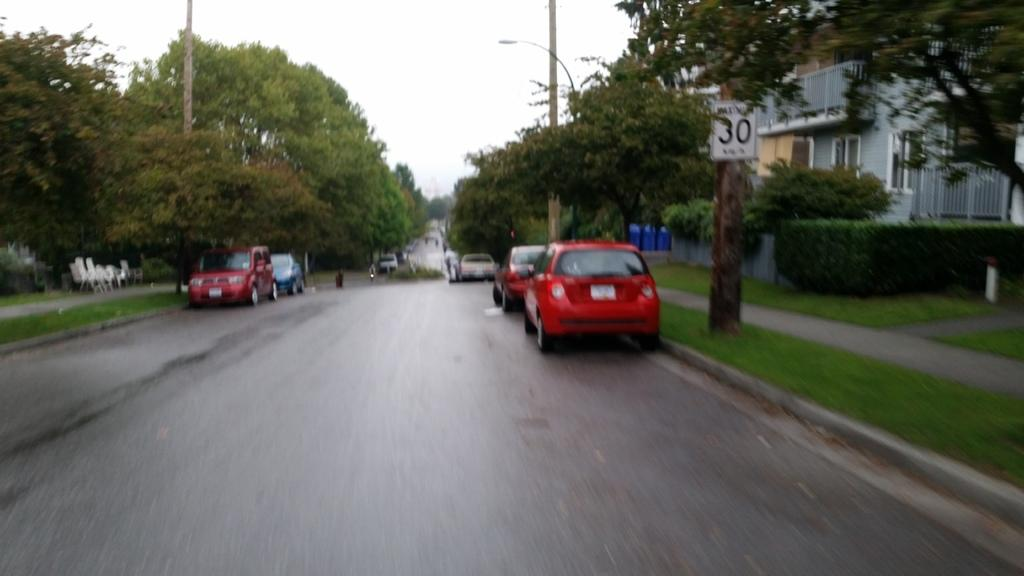What type of natural elements can be seen in the image? There are trees visible in the image. What type of man-made objects can be seen in the image? There are cars, poles, and a building visible in the image. What is the primary feature in the center of the image? There is a road in the center of the image. Where is the building located in the image? The building is in the right top corner of the image. What type of prose is being recited by the trees in the image? There is no indication in the image that the trees are reciting any prose. What type of stone is being used to construct the poles in the image? There is no indication in the image of the material used to construct the poles. 